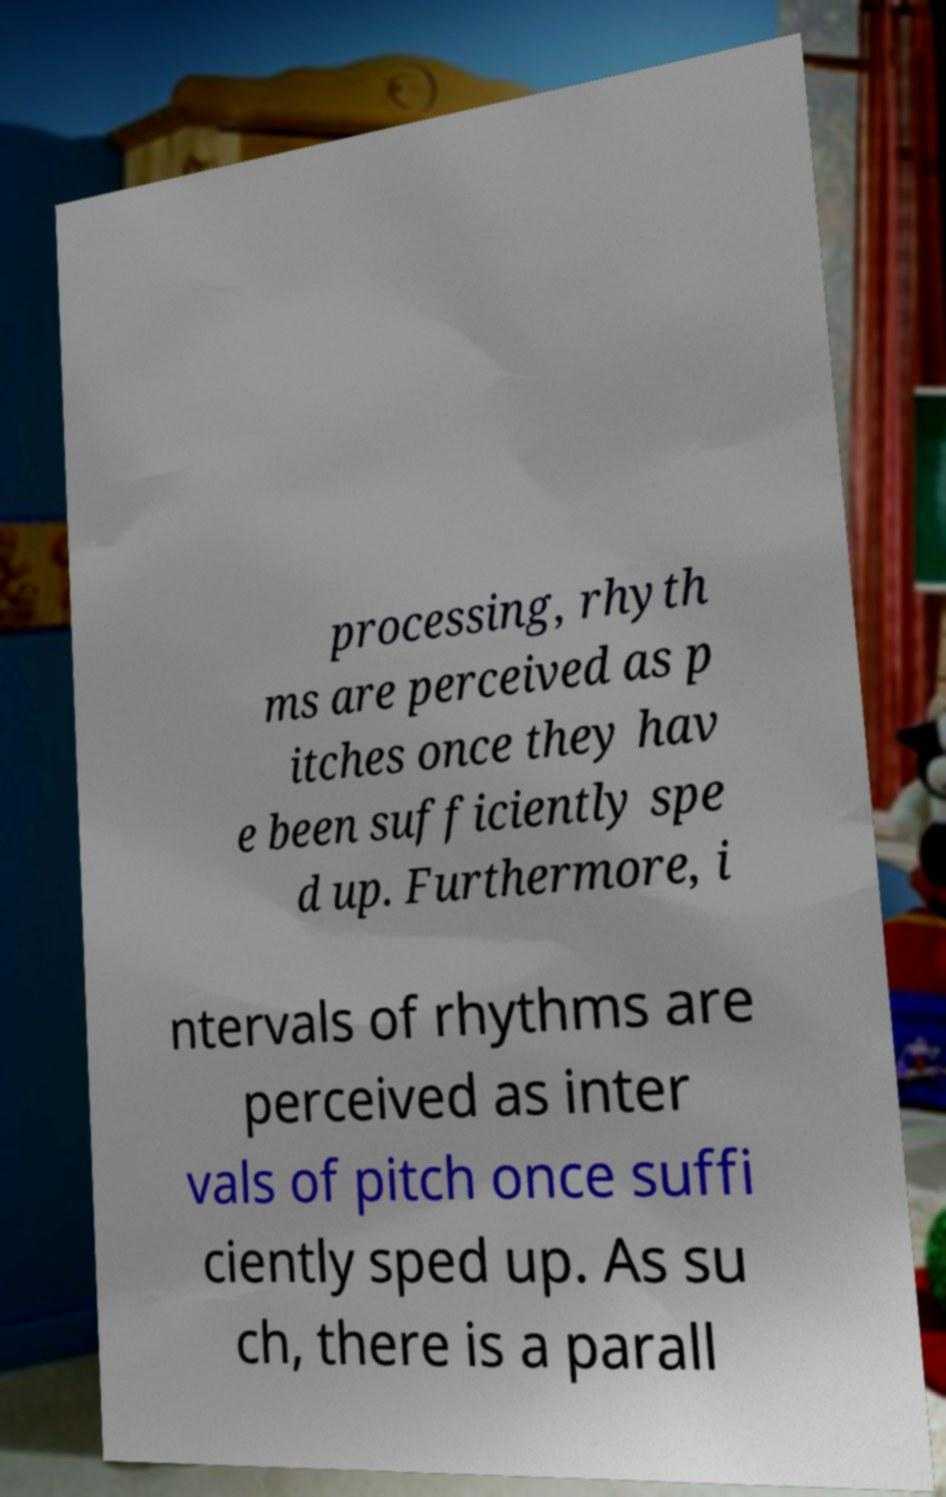Please identify and transcribe the text found in this image. processing, rhyth ms are perceived as p itches once they hav e been sufficiently spe d up. Furthermore, i ntervals of rhythms are perceived as inter vals of pitch once suffi ciently sped up. As su ch, there is a parall 